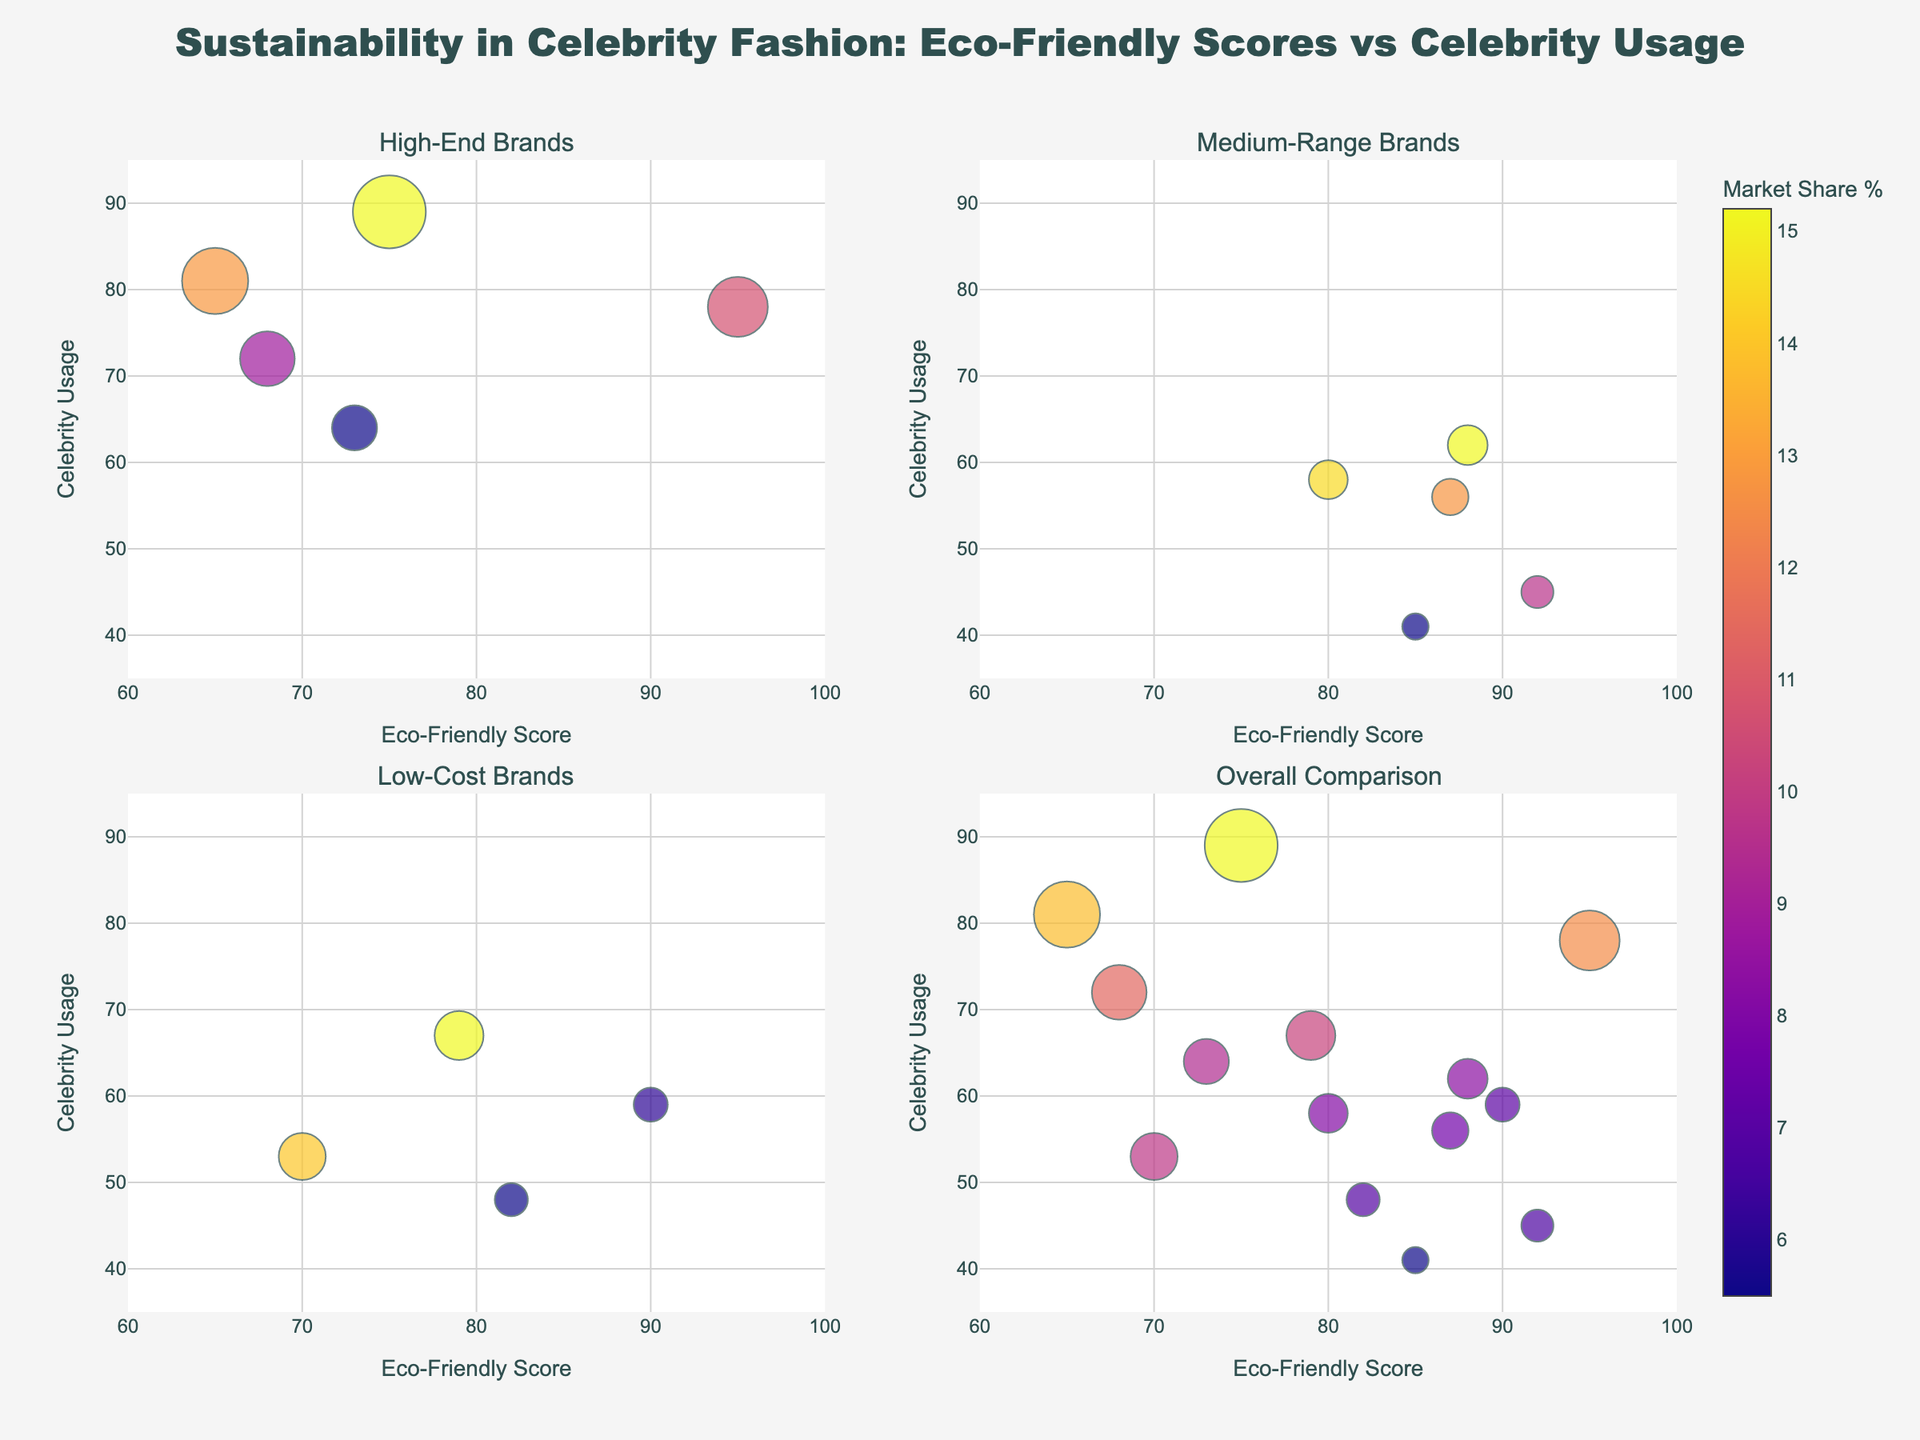What are the axes labels in the plots? The x-axis is labeled "Eco-Friendly Score" and the y-axis is labeled "Celebrity Usage". These labels are present in each subplot and signify the metrics being compared.
Answer: Eco-Friendly Score (x-axis), Celebrity Usage (y-axis) Which brand in the high-end price range has the lowest eco-friendly score? In the high-end subplot, looking at the x-axis, Prada has the lowest eco-friendly score with a score of 65.
Answer: Prada How many brands are represented in the overall comparison subplot? In the overall comparison subplot, you can count the number of bubbles representing different brands. There are 14 brands in total.
Answer: 14 Which brand has the highest market share and how can you tell? Gucci has the highest market share, which is evident by the largest bubble size in the high-end subplot or overall comparison plot.
Answer: Gucci Compare Stella McCartney and Gucci in terms of eco-friendly score and celebrity usage. Stella McCartney has an eco-friendly score of 95 and a celebrity usage of 78. Gucci, on the other hand, has an eco-friendly score of 75 and a celebrity usage of 89. In terms of eco-friendly score, Stella McCartney is higher, but Gucci has higher celebrity usage.
Answer: Stella McCartney has higher eco-friendly score but lower celebrity usage compared to Gucci Which medium-range brand has the highest celebrity usage? In the medium-range subplot, the brand with the highest position on the y-axis (celebrity usage) is Reformation with a celebrity usage of 62.
Answer: Reformation What is the difference in eco-friendly score between Veja and Levi's? The eco-friendly score of Veja is 90 and Levi's is 79. The difference is 90 - 79 = 11.
Answer: 11 Which high-end brand has a higher celebrity usage, Gucci or Burberry? By looking at the y-axis in the high-end subplot, Gucci has a higher celebrity usage (89) compared to Burberry (72).
Answer: Gucci What is the relationship between eco-friendly score and market share for Patagonia? In the medium-range subplot, Patagonia is represented by a bubble with an eco-friendly score of 92 and visually, its market share is smaller compared to other brands like Reformation. This means Patagonia has a high eco-friendly score but a lower market share.
Answer: High eco-friendly score, lower market share How does the eco-friendly score for Eileen Fisher compare to Everlane? Eileen Fisher and Everlane are both in the medium and low-cost subplots respectively. Eileen Fisher has an eco-friendly score of 85 while Everlane has a score of 82. So, Eileen Fisher has a slightly higher eco-friendly score.
Answer: Eileen Fisher has a slightly higher eco-friendly score 